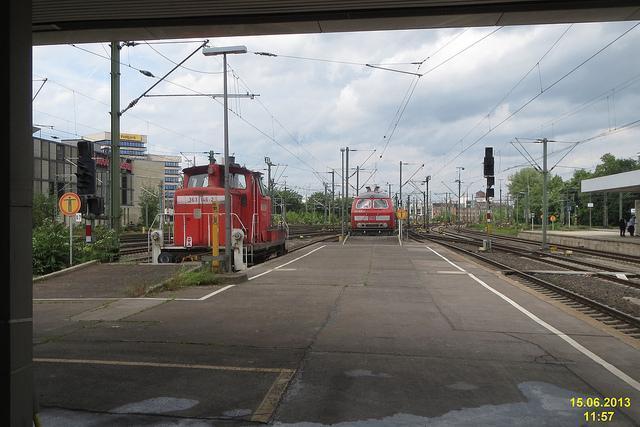How many years back the photograph was taken?
Answer the question by selecting the correct answer among the 4 following choices.
Options: Ten, eight, five, seven. Eight. 